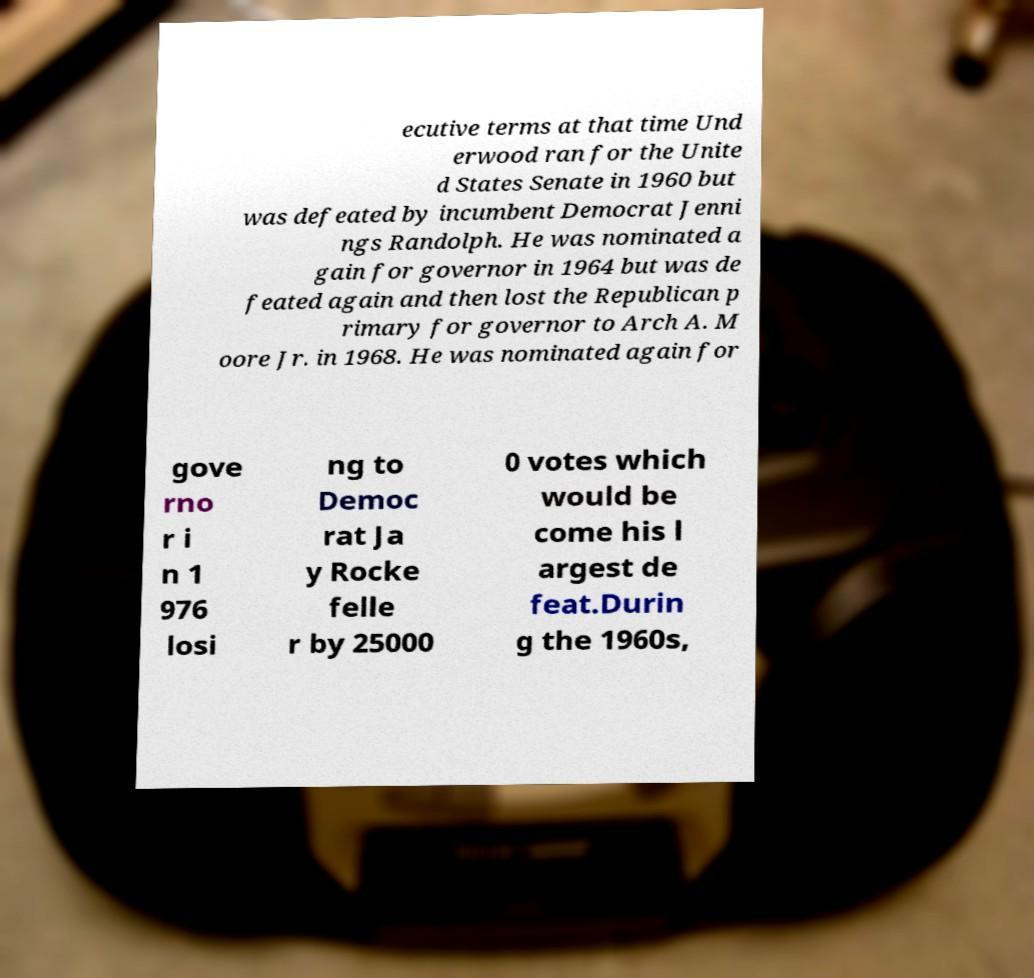There's text embedded in this image that I need extracted. Can you transcribe it verbatim? ecutive terms at that time Und erwood ran for the Unite d States Senate in 1960 but was defeated by incumbent Democrat Jenni ngs Randolph. He was nominated a gain for governor in 1964 but was de feated again and then lost the Republican p rimary for governor to Arch A. M oore Jr. in 1968. He was nominated again for gove rno r i n 1 976 losi ng to Democ rat Ja y Rocke felle r by 25000 0 votes which would be come his l argest de feat.Durin g the 1960s, 